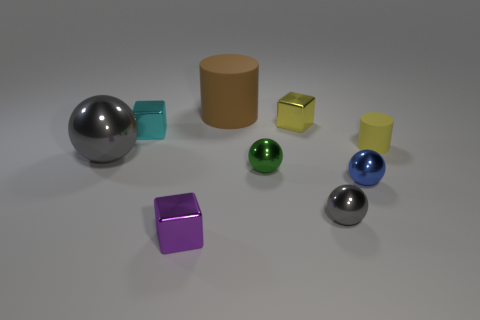There is a cube that is in front of the gray metal ball to the left of the tiny purple block; what number of tiny cyan shiny objects are in front of it?
Keep it short and to the point. 0. There is another large thing that is the same shape as the blue object; what color is it?
Offer a very short reply. Gray. What shape is the rubber thing behind the tiny block on the right side of the block that is in front of the yellow matte object?
Give a very brief answer. Cylinder. What is the size of the thing that is left of the small purple metal thing and in front of the small cyan metallic thing?
Keep it short and to the point. Large. Are there fewer small balls than large green matte cylinders?
Your answer should be compact. No. How big is the gray object that is left of the big brown rubber cylinder?
Your answer should be very brief. Large. What shape is the tiny shiny thing that is both right of the small purple cube and behind the green object?
Offer a very short reply. Cube. The blue object that is the same shape as the tiny green object is what size?
Ensure brevity in your answer.  Small. What number of yellow objects have the same material as the cyan thing?
Provide a succinct answer. 1. There is a large shiny sphere; does it have the same color as the tiny sphere that is in front of the blue sphere?
Offer a very short reply. Yes. 